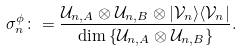<formula> <loc_0><loc_0><loc_500><loc_500>\sigma _ { n } ^ { \phi } \colon = \frac { \mathcal { U } _ { n , A } \otimes \mathcal { U } _ { n , B } \otimes | \mathcal { V } _ { n } \rangle \langle \mathcal { V } _ { n } | } { \dim \left \{ \mathcal { U } _ { n , A } \otimes \mathcal { U } _ { n , B } \right \} } .</formula> 